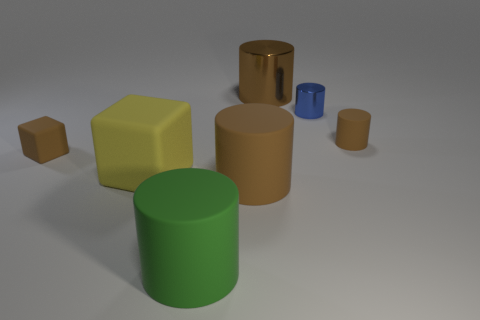The metallic thing that is the same color as the small cube is what size?
Make the answer very short. Large. The small object that is to the right of the big yellow matte block and in front of the blue shiny object has what shape?
Provide a short and direct response. Cylinder. Is the size of the brown metallic cylinder the same as the green matte cylinder?
Offer a very short reply. Yes. There is a small brown block; how many big cubes are on the right side of it?
Your response must be concise. 1. Is the number of small blue metal objects that are in front of the large yellow object the same as the number of tiny blocks that are behind the big brown rubber cylinder?
Give a very brief answer. No. There is a tiny brown matte object that is on the right side of the tiny metallic thing; is it the same shape as the green object?
Your answer should be very brief. Yes. Is there anything else that has the same material as the big cube?
Provide a succinct answer. Yes. Do the blue metallic cylinder and the rubber thing on the right side of the blue object have the same size?
Offer a terse response. Yes. How many other objects are the same color as the large metallic object?
Your response must be concise. 3. There is a big yellow matte thing; are there any large yellow cubes to the right of it?
Provide a succinct answer. No. 